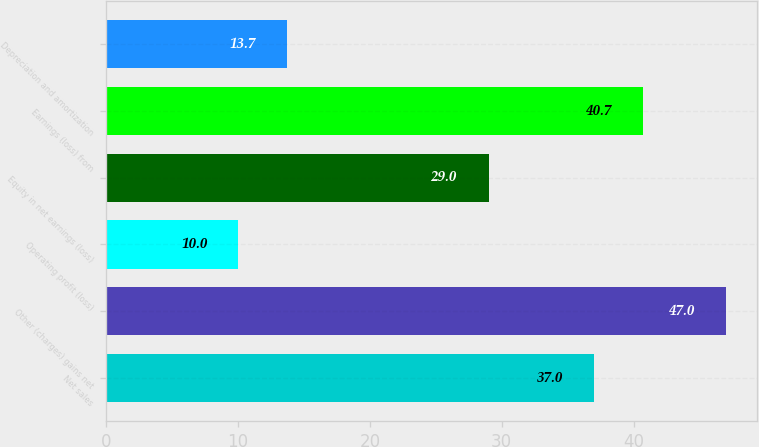Convert chart. <chart><loc_0><loc_0><loc_500><loc_500><bar_chart><fcel>Net sales<fcel>Other (charges) gains net<fcel>Operating profit (loss)<fcel>Equity in net earnings (loss)<fcel>Earnings (loss) from<fcel>Depreciation and amortization<nl><fcel>37<fcel>47<fcel>10<fcel>29<fcel>40.7<fcel>13.7<nl></chart> 